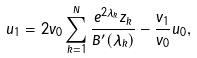Convert formula to latex. <formula><loc_0><loc_0><loc_500><loc_500>u _ { 1 } = 2 v _ { 0 } \sum _ { k = 1 } ^ { N } \frac { e ^ { 2 \lambda _ { k } } z _ { k } } { B ^ { \prime } ( \lambda _ { k } ) } - \frac { v _ { 1 } } { v _ { 0 } } u _ { 0 } ,</formula> 